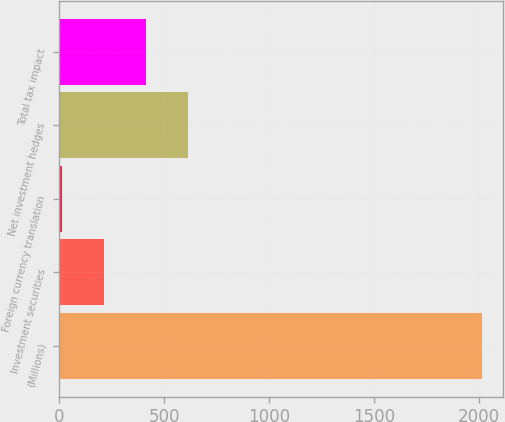<chart> <loc_0><loc_0><loc_500><loc_500><bar_chart><fcel>(Millions)<fcel>Investment securities<fcel>Foreign currency translation<fcel>Net investment hedges<fcel>Total tax impact<nl><fcel>2016<fcel>215.1<fcel>15<fcel>615.3<fcel>415.2<nl></chart> 